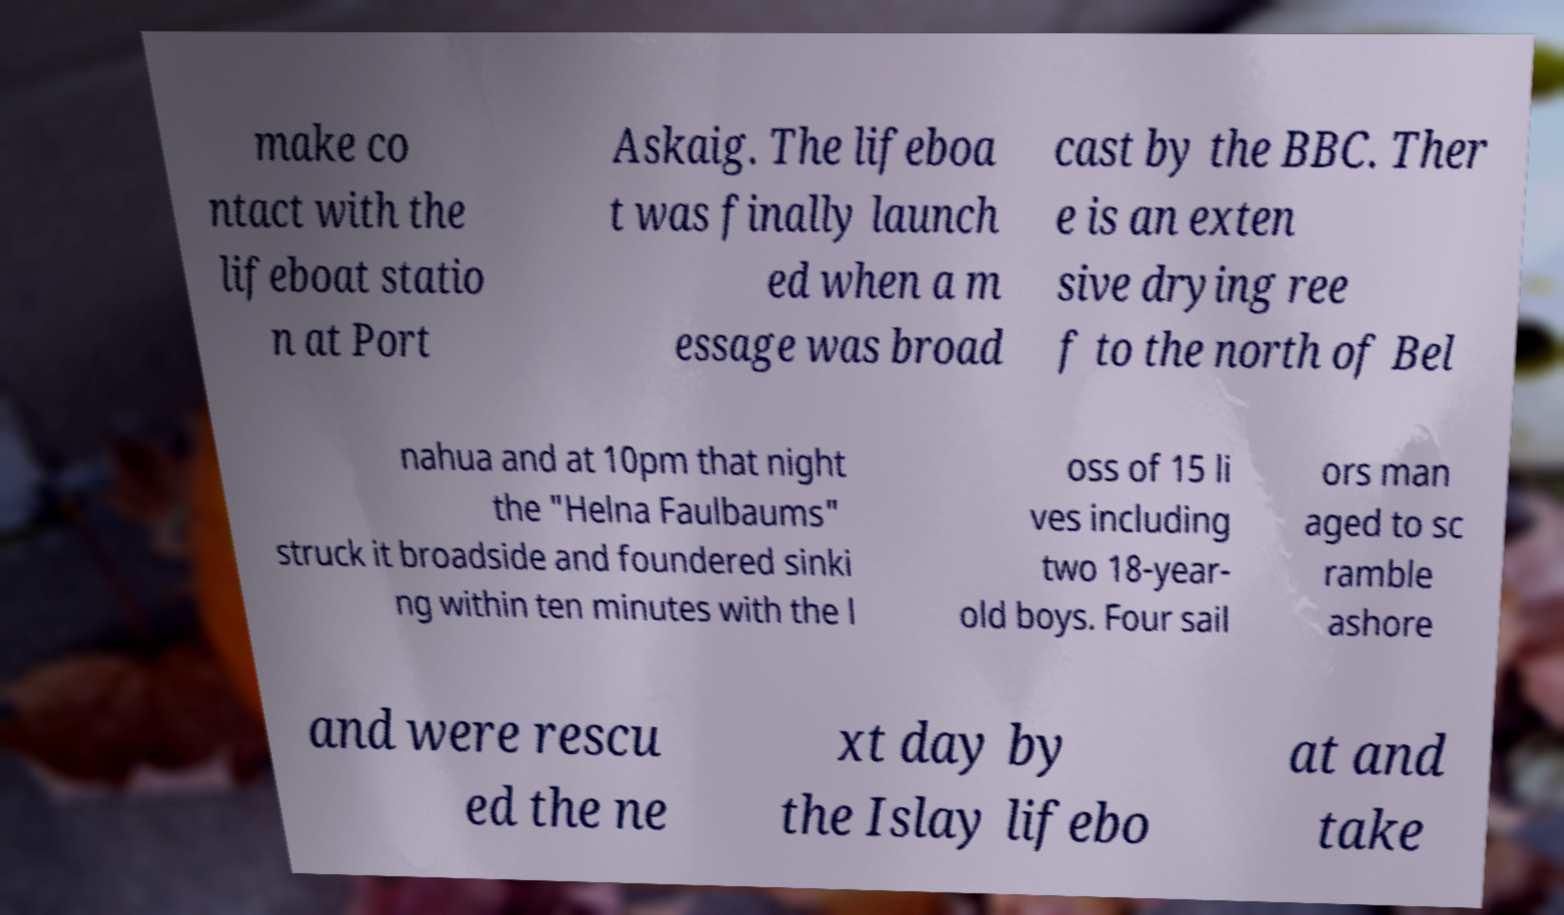Please read and relay the text visible in this image. What does it say? make co ntact with the lifeboat statio n at Port Askaig. The lifeboa t was finally launch ed when a m essage was broad cast by the BBC. Ther e is an exten sive drying ree f to the north of Bel nahua and at 10pm that night the "Helna Faulbaums" struck it broadside and foundered sinki ng within ten minutes with the l oss of 15 li ves including two 18-year- old boys. Four sail ors man aged to sc ramble ashore and were rescu ed the ne xt day by the Islay lifebo at and take 